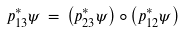<formula> <loc_0><loc_0><loc_500><loc_500>p _ { 1 3 } ^ { * } \psi \, = \, \left ( p _ { 2 3 } ^ { * } \psi \right ) \circ \left ( p _ { 1 2 } ^ { * } \psi \right )</formula> 